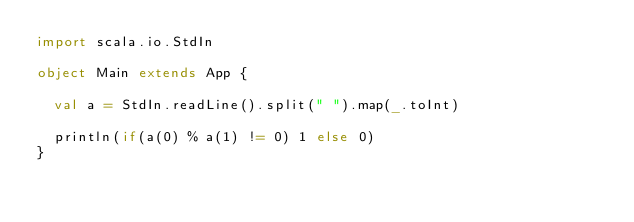<code> <loc_0><loc_0><loc_500><loc_500><_Scala_>import scala.io.StdIn

object Main extends App {

  val a = StdIn.readLine().split(" ").map(_.toInt)

  println(if(a(0) % a(1) != 0) 1 else 0)
}
</code> 